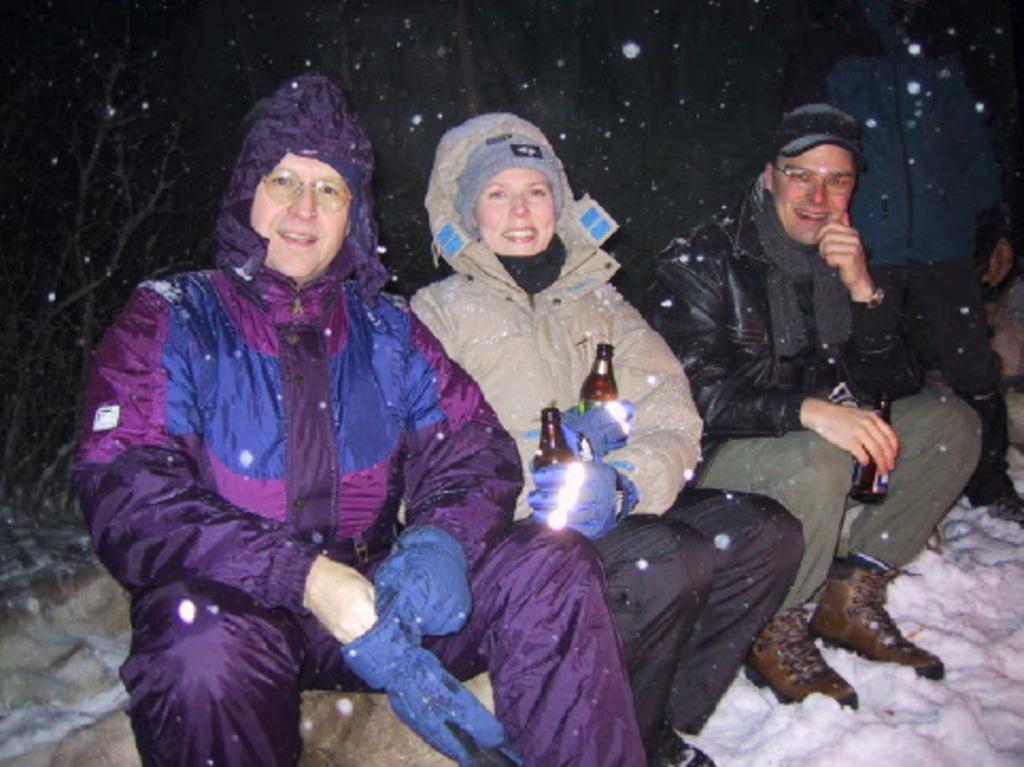Please provide a concise description of this image. These people wore jackets. These two people are holding bottles. Land is covered with snow. 